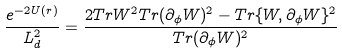<formula> <loc_0><loc_0><loc_500><loc_500>\frac { e ^ { - 2 U ( r ) } } { L _ { d } ^ { 2 } } = \frac { 2 T r W ^ { 2 } T r ( \partial _ { \phi } W ) ^ { 2 } - T r \{ W , \partial _ { \phi } W \} ^ { 2 } } { T r ( \partial _ { \phi } W ) ^ { 2 } }</formula> 